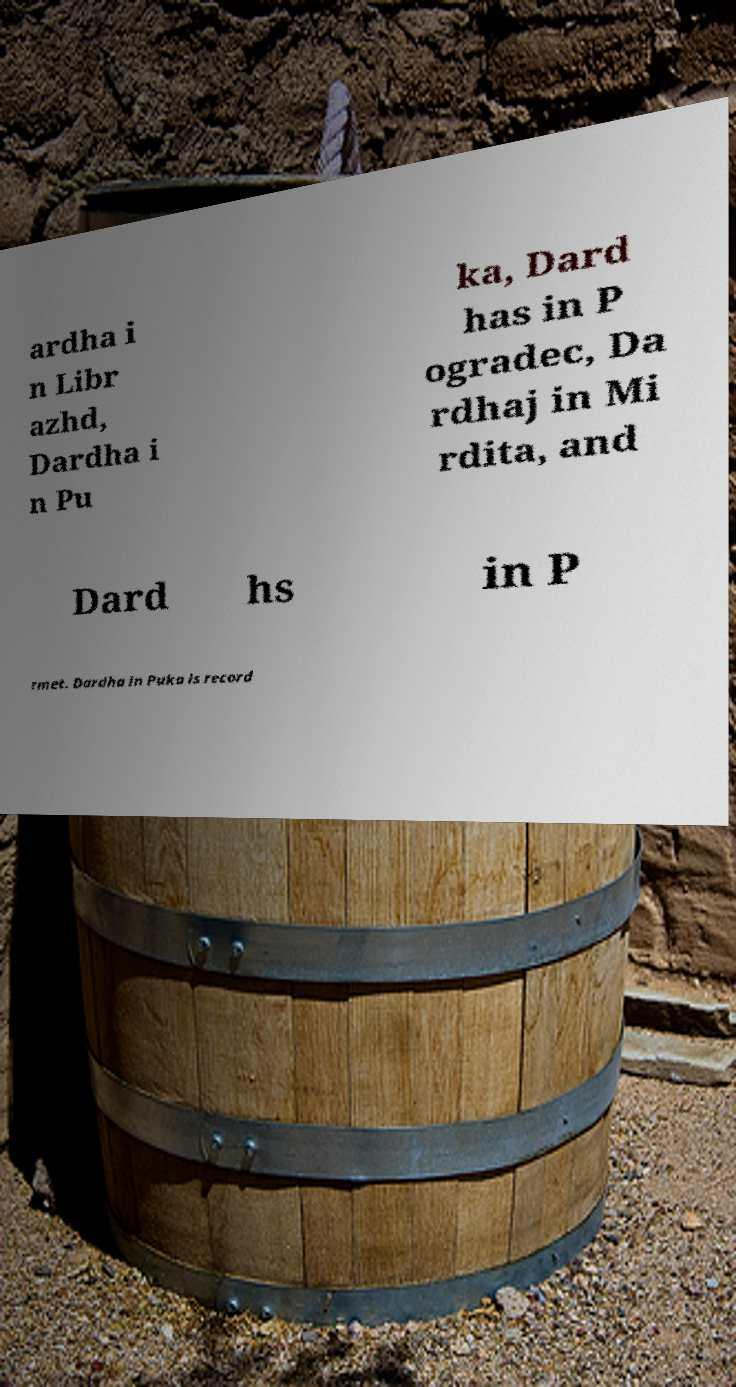I need the written content from this picture converted into text. Can you do that? ardha i n Libr azhd, Dardha i n Pu ka, Dard has in P ogradec, Da rdhaj in Mi rdita, and Dard hs in P rmet. Dardha in Puka is record 